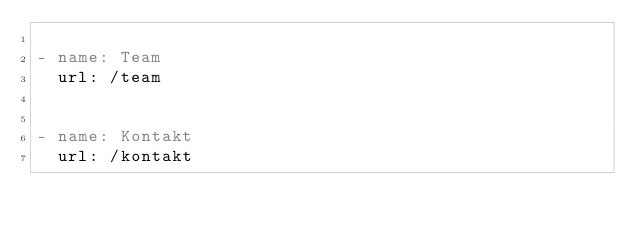<code> <loc_0><loc_0><loc_500><loc_500><_YAML_>
- name: Team
  url: /team


- name: Kontakt
  url: /kontakt
</code> 